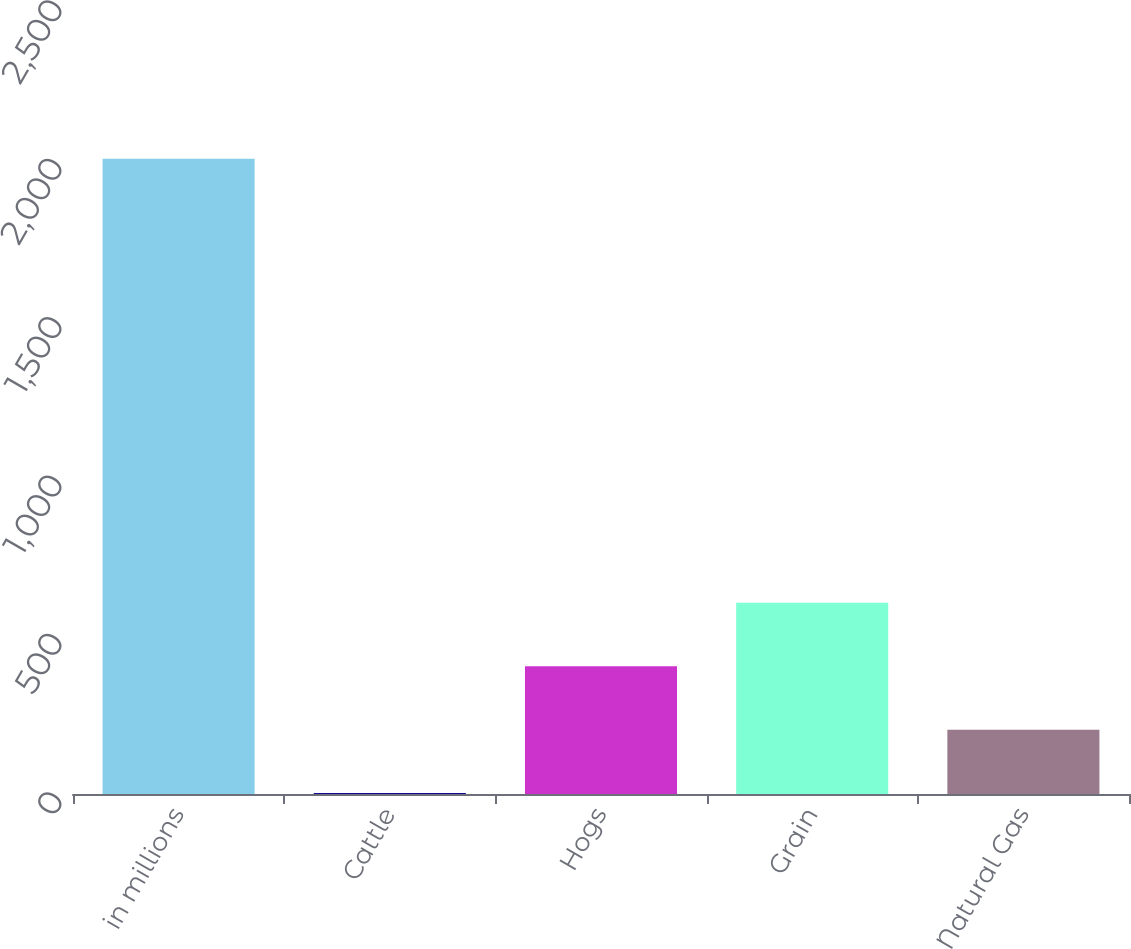<chart> <loc_0><loc_0><loc_500><loc_500><bar_chart><fcel>in millions<fcel>Cattle<fcel>Hogs<fcel>Grain<fcel>Natural Gas<nl><fcel>2005<fcel>3<fcel>403.4<fcel>603.6<fcel>203.2<nl></chart> 